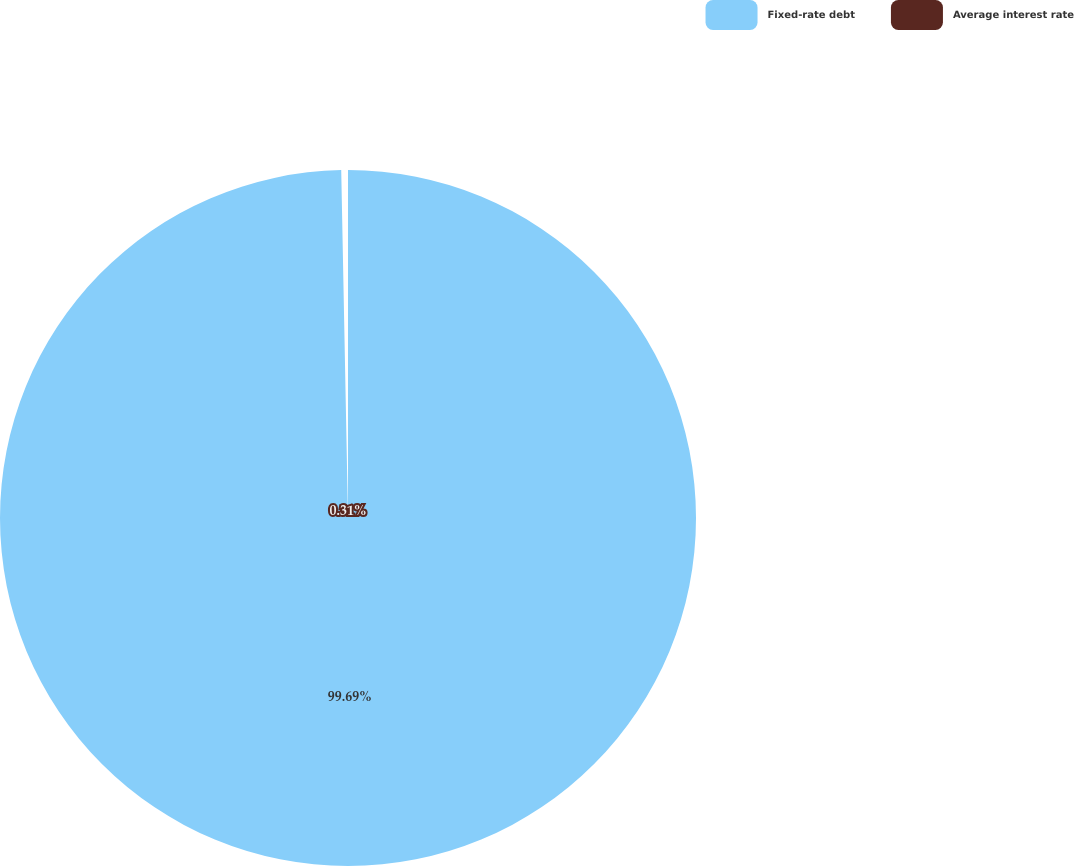<chart> <loc_0><loc_0><loc_500><loc_500><pie_chart><fcel>Fixed-rate debt<fcel>Average interest rate<nl><fcel>99.69%<fcel>0.31%<nl></chart> 